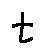Convert formula to latex. <formula><loc_0><loc_0><loc_500><loc_500>t</formula> 